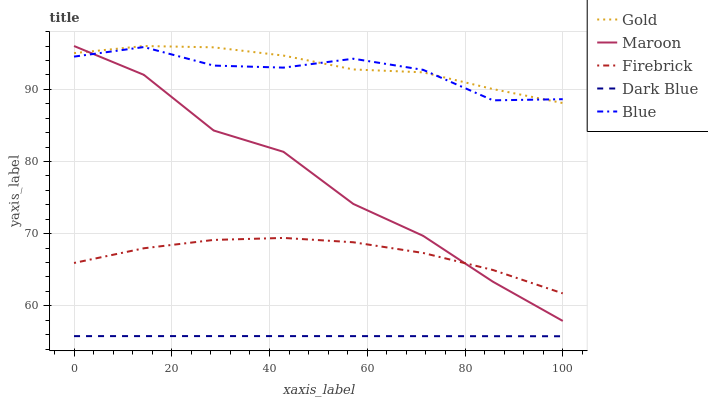Does Dark Blue have the minimum area under the curve?
Answer yes or no. Yes. Does Gold have the maximum area under the curve?
Answer yes or no. Yes. Does Firebrick have the minimum area under the curve?
Answer yes or no. No. Does Firebrick have the maximum area under the curve?
Answer yes or no. No. Is Dark Blue the smoothest?
Answer yes or no. Yes. Is Maroon the roughest?
Answer yes or no. Yes. Is Firebrick the smoothest?
Answer yes or no. No. Is Firebrick the roughest?
Answer yes or no. No. Does Dark Blue have the lowest value?
Answer yes or no. Yes. Does Firebrick have the lowest value?
Answer yes or no. No. Does Gold have the highest value?
Answer yes or no. Yes. Does Firebrick have the highest value?
Answer yes or no. No. Is Dark Blue less than Maroon?
Answer yes or no. Yes. Is Firebrick greater than Dark Blue?
Answer yes or no. Yes. Does Maroon intersect Blue?
Answer yes or no. Yes. Is Maroon less than Blue?
Answer yes or no. No. Is Maroon greater than Blue?
Answer yes or no. No. Does Dark Blue intersect Maroon?
Answer yes or no. No. 